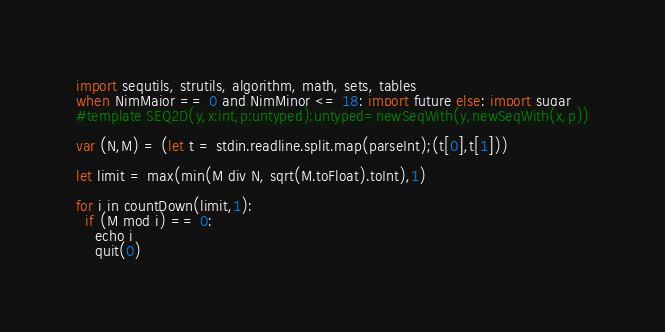Convert code to text. <code><loc_0><loc_0><loc_500><loc_500><_Nim_>import sequtils, strutils, algorithm, math, sets, tables
when NimMajor == 0 and NimMinor <= 18: import future else: import sugar
#template SEQ2D(y,x:int,p:untyped):untyped=newSeqWith(y,newSeqWith(x,p))

var (N,M) = (let t = stdin.readline.split.map(parseInt);(t[0],t[1]))

let limit = max(min(M div N, sqrt(M.toFloat).toInt),1)

for i in countDown(limit,1):
  if (M mod i) == 0:
    echo i
    quit(0)</code> 